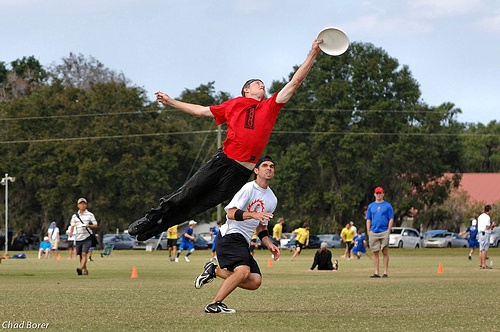Describe the objects in this image and their specific colors. I can see people in lavender, black, red, brown, and tan tones, people in lavender, black, brown, and darkgray tones, people in lavender, blue, gray, tan, and darkgray tones, people in lavender, lightgray, black, darkgray, and gray tones, and people in lavender, black, tan, and gray tones in this image. 